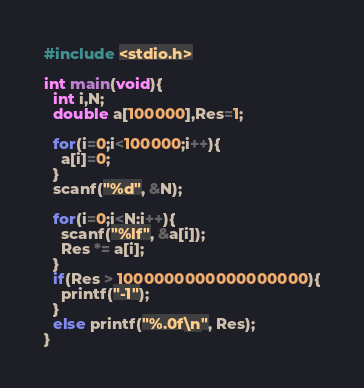<code> <loc_0><loc_0><loc_500><loc_500><_C_>#include <stdio.h>

int main(void){
  int i,N;
  double a[100000],Res=1;

  for(i=0;i<100000;i++){
    a[i]=0;
  }
  scanf("%d", &N);

  for(i=0;i<N;i++){
    scanf("%lf", &a[i]);
    Res *= a[i];
  }
  if(Res > 1000000000000000000){
    printf("-1");
  }
  else printf("%.0f\n", Res);
}</code> 